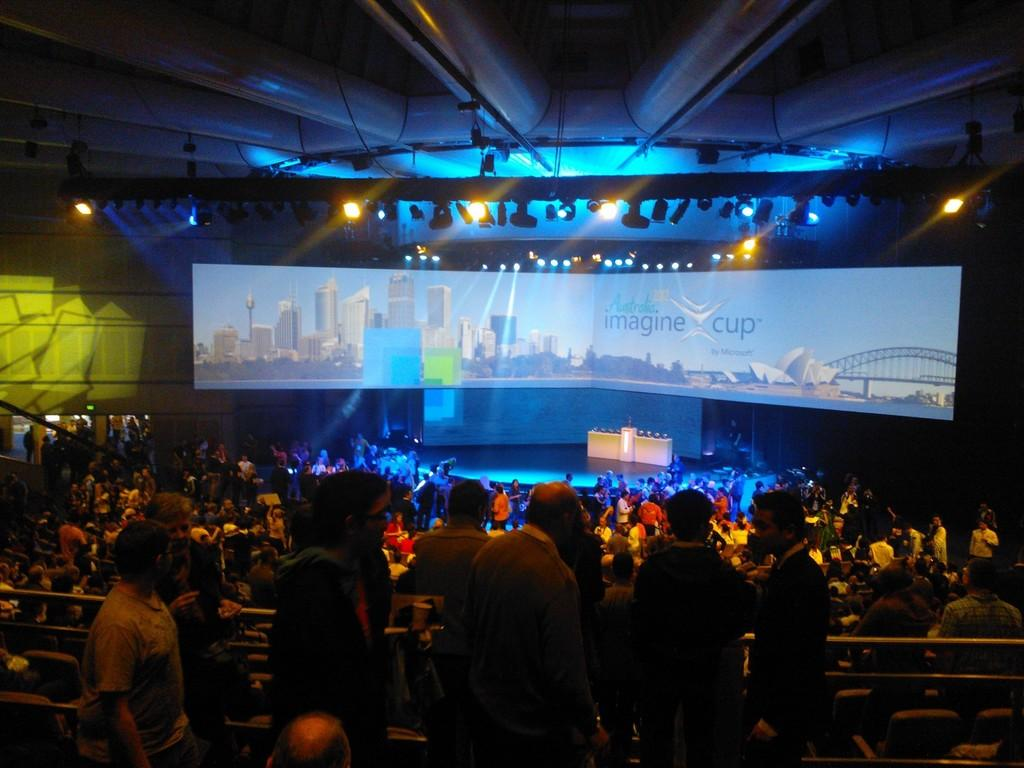What type of venue is depicted in the image? There is an auditorium in the image. How many people can be seen in the image? There are many people in the image. What type of technology is present in the auditorium? There is a digital screen in the image. What can be observed about the lighting in the auditorium? There are many lights in the image. Where is the sofa located in the image? There is no sofa present in the image. What type of bone can be seen in the image? There are no bones present in the image. 